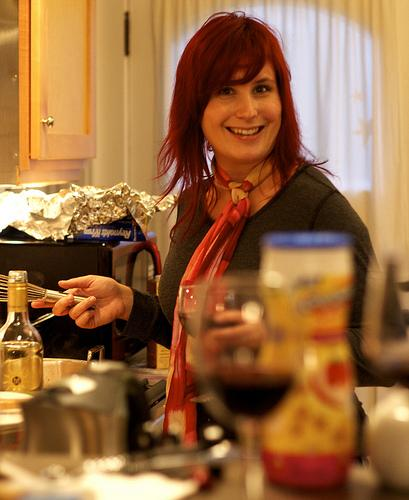In the image, can you describe the setting, considering factors like the lighting and other details in the background? The setting appears to be a kitchen or a living space with a white curtain panel behind the woman and sunlight filtering through the curtain. There are stars woven into the curtain panel. Based on the woman's expression and other visual details, determine her mood in the image. The woman's mood appears to be happy, as she is smiling and wearing a brightly colored neck scarf. Count the total number of objects related to the woman's appearance and describe them. There are 10 objects related to the woman's appearance: auburn hair, dark shirt, colorful scarf, straight white teeth, bright neck scarf, grotesque red hair, modern red hair, green top, and her hand and thumb. Analyze the sentiment that the image might evoke in the viewer. The image evokes a cheerful sentiment due to the woman's happy expression, the colorful scarf she's wearing, and the brightness of the sunlight. Describe any possible interaction between two or more objects in the image. The woman is holding an egg whisk in her hand, possibly interacting with other kitchen objects, like the microwave or the bottle of olive oil. Among the objects detected in the image, can you find a small object that might go unnoticed at first glance? Yes, a metal handle on the cabinet might go unnoticed at first glance. How many women with different descriptions appear in the image? There are five distinct descriptions of women mentioned. What is the woman in the image holding in her hand? The woman is holding an egg whisk in her hand. Identify the primary object in the image and describe its appearance. A woman with auburn hair wearing a dark shirt and a colorful scarf, holding an egg whisk. Enumerate the objects in the image related to the kitchen. Stainless steel wire whisk, extra virgin olive oil, red and black microwave oven, wine glass of red wine, cabinet on the wall, and a bottle of olive oil. Identify objects that pose potential anomalies in the image. Stars woven into the curtain panel, woman with grotesque red hair In the context of the image, what might be the relationship between the woman and the wine glass in the background? The woman may be holding the wine glass. What are the positions and dimensions of the happy woman? X:157 Y:7 Width:186 Height:186 Count the number of women depicted in the image. 4 Provide a summary of the scene in the image. A woman with auburn hair wearing a colorful scarf and a green top is holding an egg whisk in the kitchen with various objects around. Is there a text visible in the image? No Is the cat visible in the background of the image? There is no mention of a cat in the image. Identify the woman who is happy in the image. Woman at X:157 Y:7 Width:186 Height:186 What material seems to be used in the kitchen cabinet handle? Metal List all the objects found in the image. Women, whisk, olive oil, microwave oven, wine glass, reynolds wrap, scarf, door hinge, curtain, cabinet, handle, aluminum foil, woman's hand, nose, mouth, colorful top, auburn hair, dark shirt, curtain panel, stars Is there a crumpled aluminum foil on the foil box? Yes Can you see the orange microwave oven in the image? The microwave oven mentioned in the image is red and black, not orange. Rate the quality of the image from 1 to 10, with 10 being the highest quality. 8 Is there a beer bottle in the woman's hand? There is no mention of a beer bottle in the image. What color is the scarf that the woman is wearing? Brightly colored Which object is being held by the woman? Egg whisk Does the woman have sunglasses on her head? There is no mention of sunglasses in the image. Is the woman with the blonde hair smiling in the image? There is no mention of a woman with blonde hair. Identify and describe the objects near the microwave oven in the image. Red and black microwave oven at X:0 Y:228 Width:162 Height:162, a bottle of extra virgin olive oil at X:0 Y:261 Width:47 Height:47, and crumpled Reynolds wrap at X:29 Y:179 Width:140 Height:140. Please identify which Sentiment task this image can be used. Image Sentiment Analysis What type of oil is in the bottle? Extra virgin olive oil Examine the expressions of the women in the picture and describe their emotions. 3 women have neutral expressions, and 1 woman is happy. Can you find the blue scarf wrapped around the woman's neck? The scarf mentioned in the image is brightly colored, not blue. 